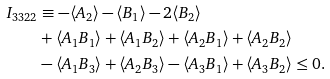Convert formula to latex. <formula><loc_0><loc_0><loc_500><loc_500>I _ { 3 3 2 2 } & \equiv - \langle A _ { 2 } \rangle - \langle B _ { 1 } \rangle - 2 \langle B _ { 2 } \rangle \\ & + \langle A _ { 1 } B _ { 1 } \rangle + \langle A _ { 1 } B _ { 2 } \rangle + \langle A _ { 2 } B _ { 1 } \rangle + \langle A _ { 2 } B _ { 2 } \rangle \\ & - \langle A _ { 1 } B _ { 3 } \rangle + \langle A _ { 2 } B _ { 3 } \rangle - \langle A _ { 3 } B _ { 1 } \rangle + \langle A _ { 3 } B _ { 2 } \rangle \leq 0 .</formula> 